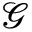<formula> <loc_0><loc_0><loc_500><loc_500>\mathcal { G }</formula> 